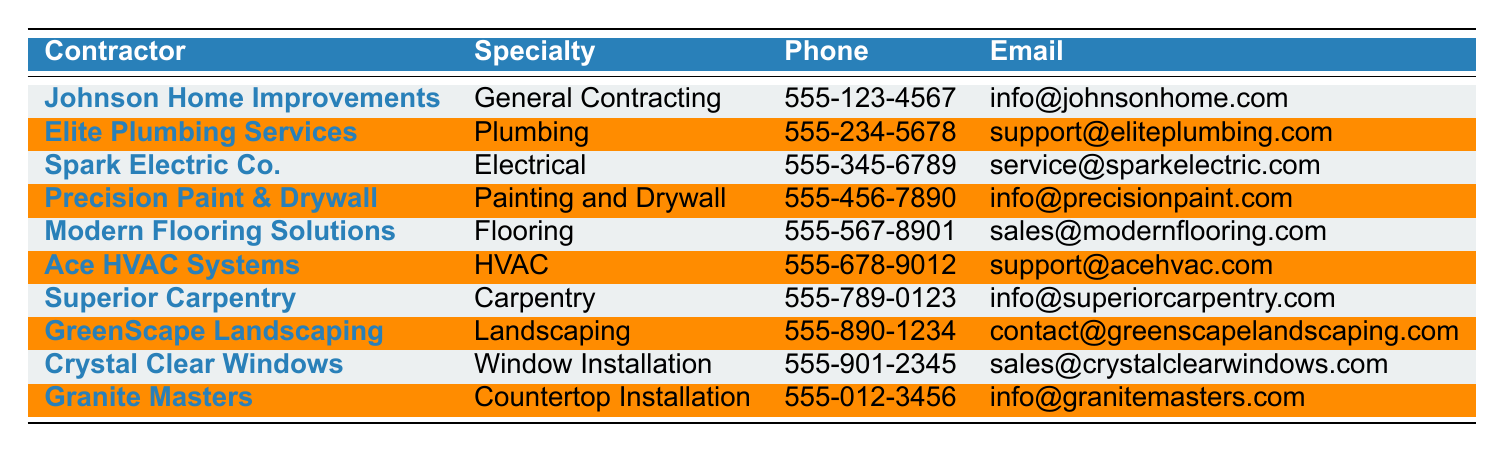What is the specialty of 'Ace HVAC Systems'? The table lists the specialty of each contractor alongside their names. Looking up 'Ace HVAC Systems', I see its specialty is 'HVAC'.
Answer: HVAC Who can I contact for plumbing services? By scanning the table, I find 'Elite Plumbing Services' under the specialty 'Plumbing', and their phone number is 555-234-5678.
Answer: Elite Plumbing Services Which contractor specializes in countertop installation? The 'Specialty' column allows for direct identification. Scanning down, I see 'Granite Masters' is listed as specializing in 'Countertop Installation'.
Answer: Granite Masters What is the phone number for 'Superior Carpentry'? The phone number associated with 'Superior Carpentry' is located in the 'Phone' column next to its name in the table, which shows 555-789-0123.
Answer: 555-789-0123 Is there a contractor in the table that specializes in landscaping? Looking through the 'Specialty' column, 'GreenScape Landscaping' is listed under 'Landscaping', confirming there is a contractor for this specialty.
Answer: Yes How many contractors in the table specialize in electrical services? Upon reviewing the 'Specialty' column, I can identify 'Spark Electric Co.' as the only contractor specializing in 'Electrical'. Thus, the count is one.
Answer: 1 Which contractor offers painting and drywall services? I can find 'Precision Paint & Drywall' in the table under the 'Specialty' section for 'Painting and Drywall' services.
Answer: Precision Paint & Drywall What is the average specialty type of contractors listed? The table contains 10 different specialties, each listed uniquely. Since they are all different, the average specialty doesn't apply meaningfully. However, I can see there are 10 total contracts with no repetition in specialties.
Answer: Not applicable Does 'Crystal Clear Windows' have an email listed? Checking the 'Email' column for 'Crystal Clear Windows', I find it has an email address: sales@crystalclearwindows.com, confirming its availability.
Answer: Yes Which contractor would you reach out to for HVAC-related work, and what’s their contact number? Upon locating 'Ace HVAC Systems' specializing in HVAC, I see the phone number listed is 555-678-9012.
Answer: Ace HVAC Systems, 555-678-9012 